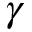<formula> <loc_0><loc_0><loc_500><loc_500>\gamma</formula> 